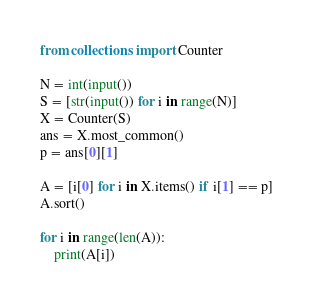Convert code to text. <code><loc_0><loc_0><loc_500><loc_500><_Python_>from collections import Counter

N = int(input())
S = [str(input()) for i in range(N)]
X = Counter(S)
ans = X.most_common()
p = ans[0][1]

A = [i[0] for i in X.items() if i[1] == p]
A.sort()

for i in range(len(A)):
    print(A[i])</code> 